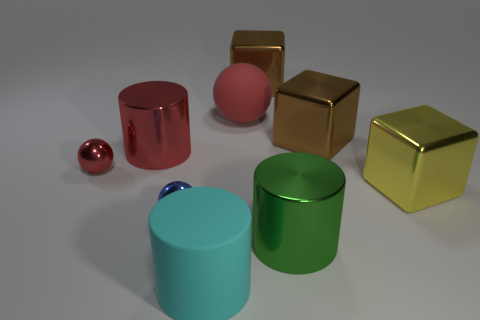Is there a big cyan thing of the same shape as the large green shiny thing?
Make the answer very short. Yes. Does the green metal object have the same size as the cylinder on the left side of the big cyan matte cylinder?
Your answer should be very brief. Yes. How many objects are large brown cubes that are on the left side of the green cylinder or objects that are behind the yellow metallic block?
Provide a succinct answer. 5. Are there more large metal things to the left of the yellow metal thing than big red metallic cylinders?
Offer a terse response. Yes. How many brown shiny spheres have the same size as the matte cylinder?
Ensure brevity in your answer.  0. Does the cylinder that is behind the tiny blue object have the same size as the red object that is to the right of the cyan matte cylinder?
Give a very brief answer. Yes. What is the size of the metal ball behind the large yellow object?
Your answer should be very brief. Small. What size is the shiny ball left of the metallic sphere that is in front of the tiny red shiny ball?
Ensure brevity in your answer.  Small. There is a red sphere that is the same size as the cyan cylinder; what is it made of?
Ensure brevity in your answer.  Rubber. Are there any green shiny objects behind the blue shiny object?
Your response must be concise. No. 